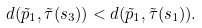<formula> <loc_0><loc_0><loc_500><loc_500>d ( \tilde { p } _ { 1 } , \tilde { \tau } ( s _ { 3 } ) ) < d ( \tilde { p } _ { 1 } , \tilde { \tau } ( s _ { 1 } ) ) .</formula> 